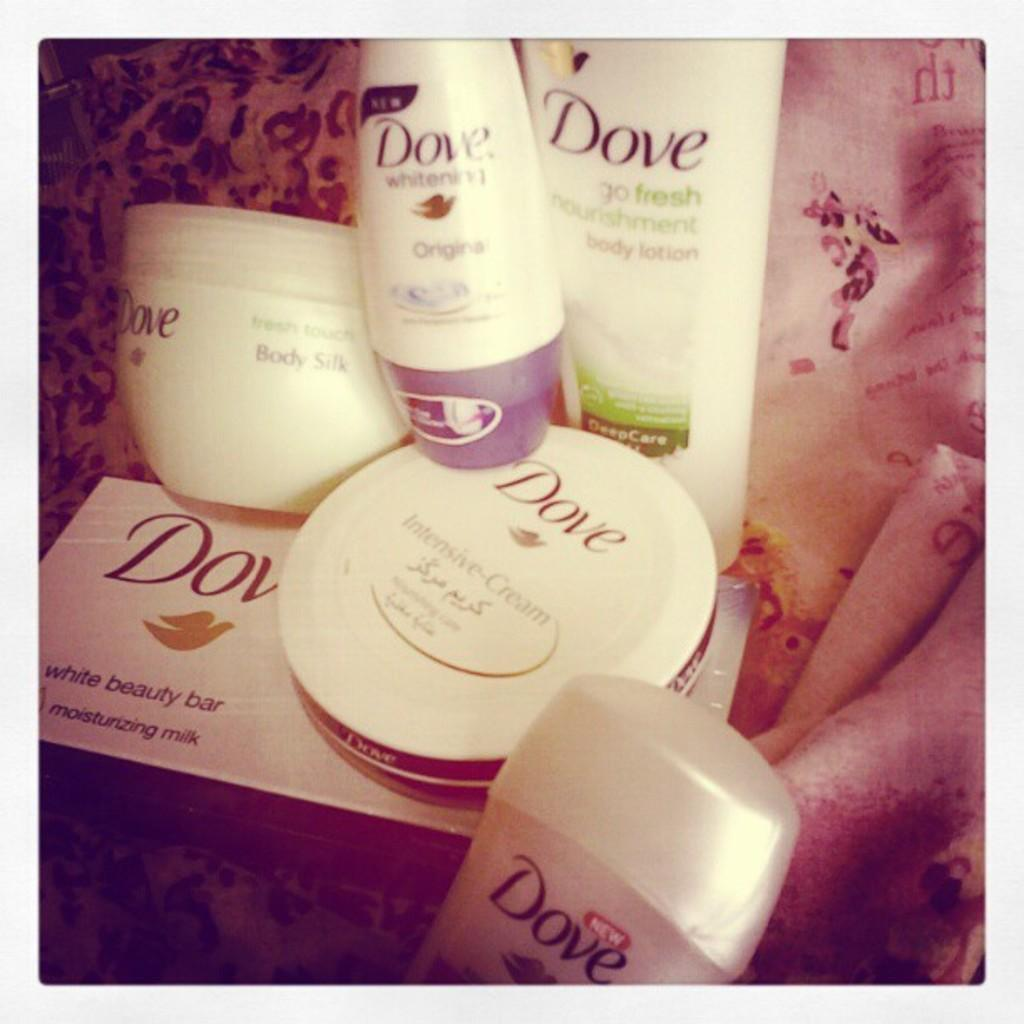<image>
Write a terse but informative summary of the picture. Several different Dove hygenie products are grouped together, including a white beauty bar and intensive cream. 